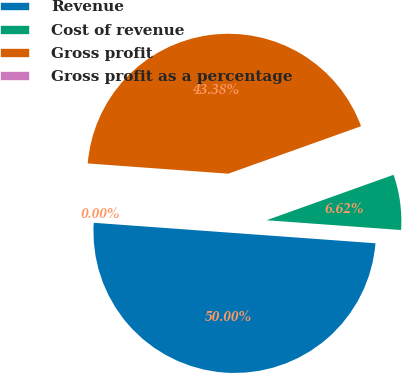Convert chart to OTSL. <chart><loc_0><loc_0><loc_500><loc_500><pie_chart><fcel>Revenue<fcel>Cost of revenue<fcel>Gross profit<fcel>Gross profit as a percentage<nl><fcel>50.0%<fcel>6.62%<fcel>43.38%<fcel>0.0%<nl></chart> 